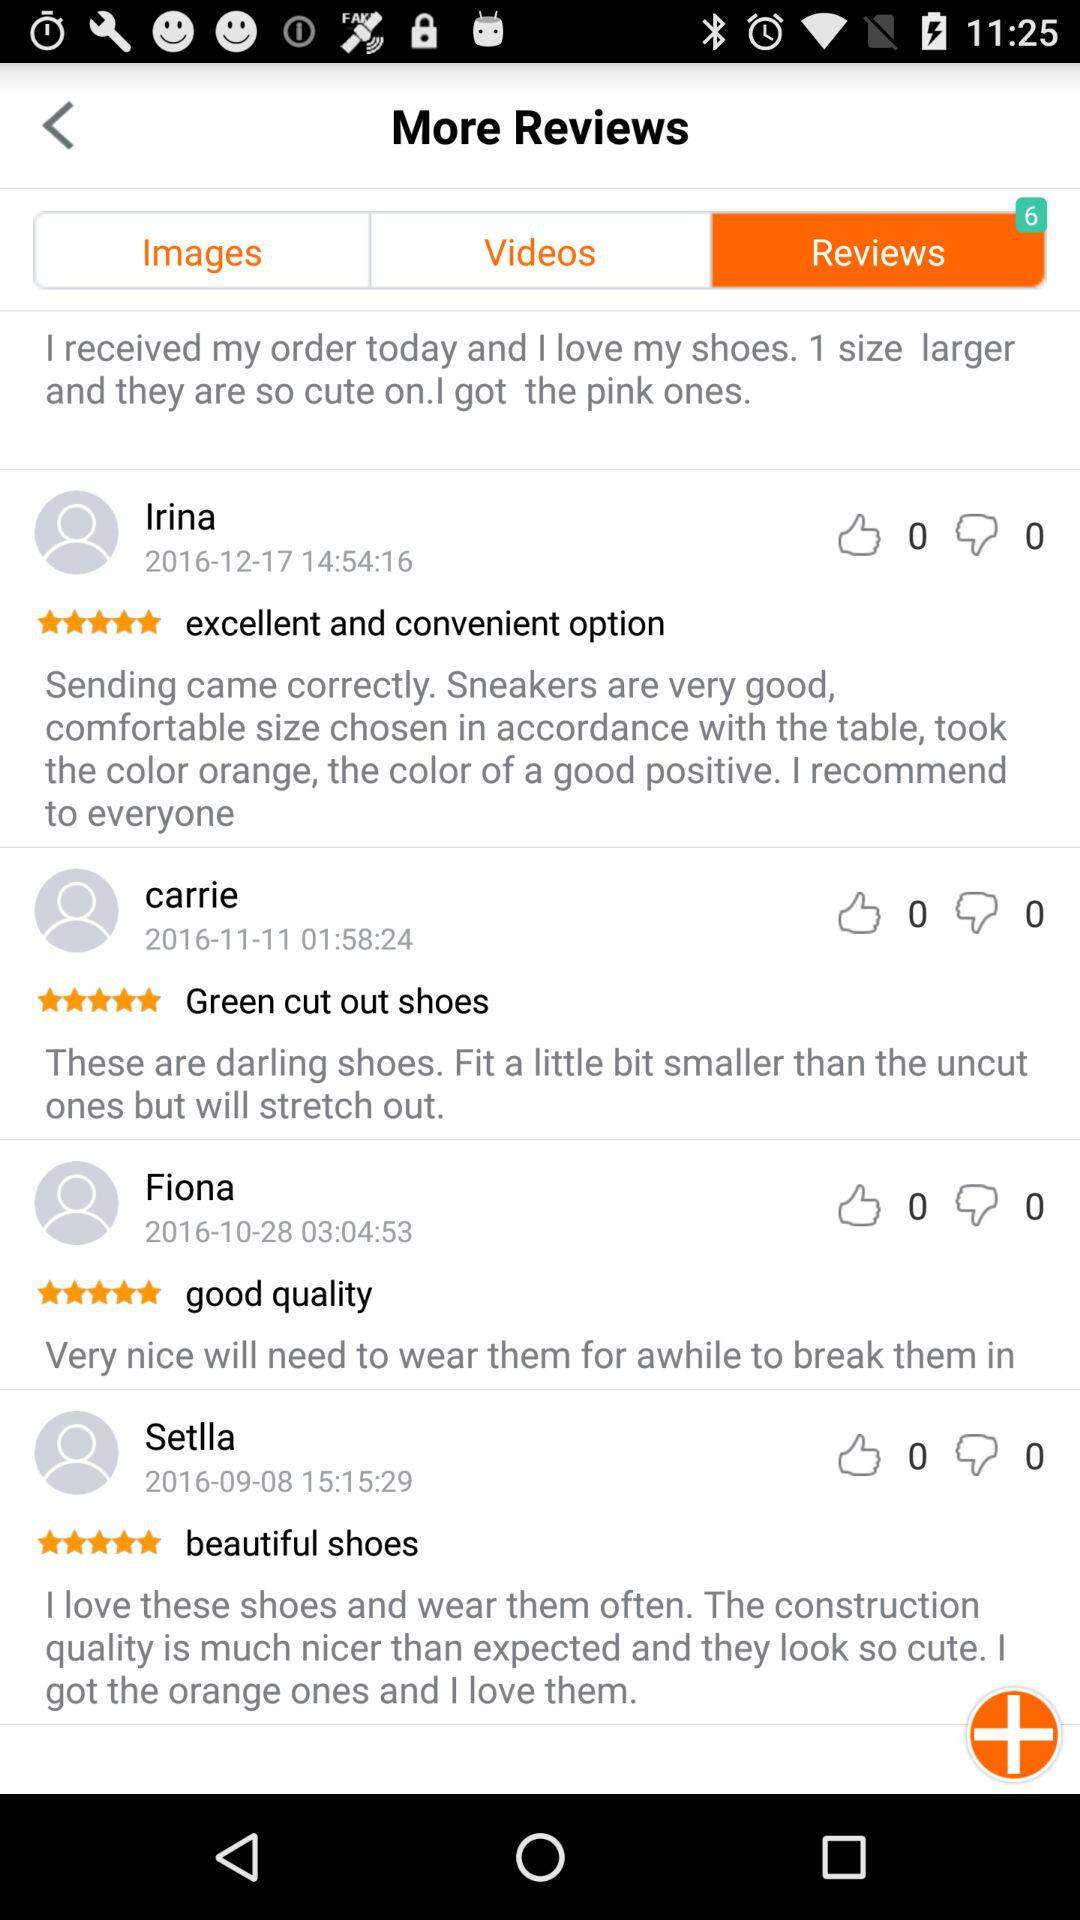How many likes are there of Irina's review? There are 0 likes of Irina's review. 